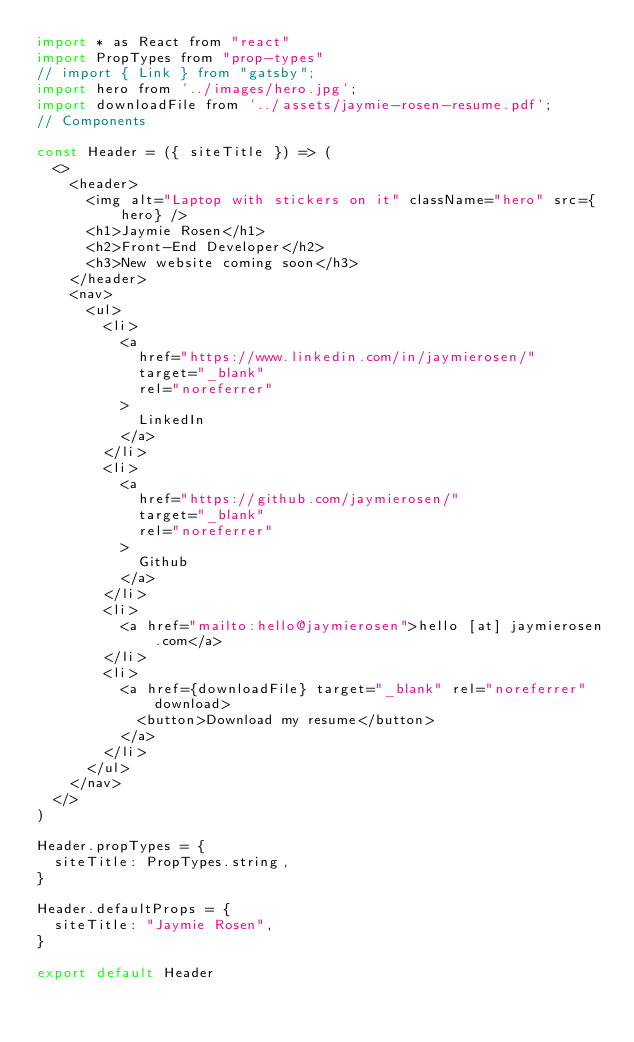<code> <loc_0><loc_0><loc_500><loc_500><_JavaScript_>import * as React from "react"
import PropTypes from "prop-types"
// import { Link } from "gatsby";
import hero from '../images/hero.jpg';
import downloadFile from '../assets/jaymie-rosen-resume.pdf';
// Components

const Header = ({ siteTitle }) => (
  <>
    <header>
      <img alt="Laptop with stickers on it" className="hero" src={hero} />
      <h1>Jaymie Rosen</h1>
      <h2>Front-End Developer</h2>
      <h3>New website coming soon</h3>
    </header>
    <nav>
      <ul>
        <li>
          <a
            href="https://www.linkedin.com/in/jaymierosen/"
            target="_blank"
            rel="noreferrer"
          >
            LinkedIn
          </a>
        </li>
        <li>
          <a
            href="https://github.com/jaymierosen/"
            target="_blank"
            rel="noreferrer"
          >
            Github
          </a>
        </li>
        <li>
          <a href="mailto:hello@jaymierosen">hello [at] jaymierosen.com</a>
        </li>
        <li>
          <a href={downloadFile} target="_blank" rel="noreferrer" download>
            <button>Download my resume</button>
          </a>
        </li>
      </ul>
    </nav>
  </>
)

Header.propTypes = {
  siteTitle: PropTypes.string,
}

Header.defaultProps = {
  siteTitle: "Jaymie Rosen",
}

export default Header
</code> 